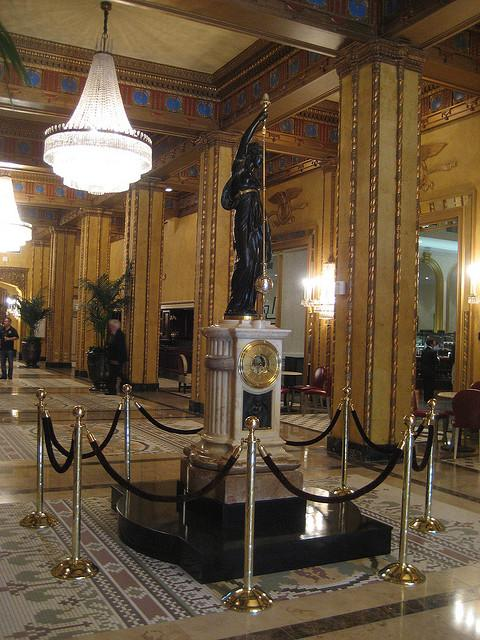Why is there a rope around this statue? protection 